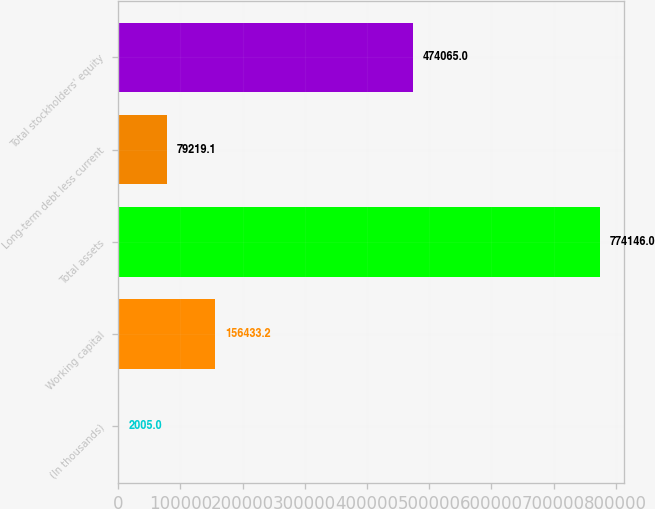Convert chart. <chart><loc_0><loc_0><loc_500><loc_500><bar_chart><fcel>(In thousands)<fcel>Working capital<fcel>Total assets<fcel>Long-term debt less current<fcel>Total stockholders' equity<nl><fcel>2005<fcel>156433<fcel>774146<fcel>79219.1<fcel>474065<nl></chart> 